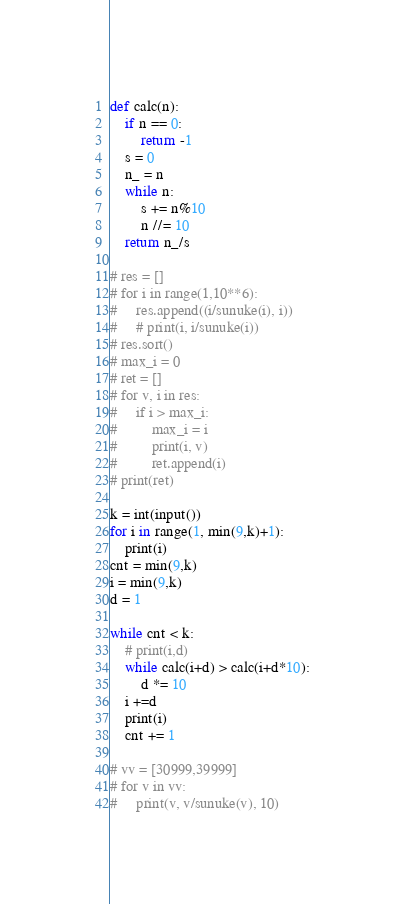<code> <loc_0><loc_0><loc_500><loc_500><_Python_>def calc(n):
    if n == 0:
        return -1
    s = 0
    n_ = n
    while n:
        s += n%10
        n //= 10
    return n_/s

# res = []
# for i in range(1,10**6):
#     res.append((i/sunuke(i), i))
#     # print(i, i/sunuke(i))
# res.sort()
# max_i = 0
# ret = []
# for v, i in res:
#     if i > max_i:
#         max_i = i
#         print(i, v)
#         ret.append(i)
# print(ret)

k = int(input())
for i in range(1, min(9,k)+1):
    print(i)
cnt = min(9,k)
i = min(9,k)
d = 1

while cnt < k:
    # print(i,d)
    while calc(i+d) > calc(i+d*10):
        d *= 10
    i +=d
    print(i)
    cnt += 1

# vv = [30999,39999]
# for v in vv:
#     print(v, v/sunuke(v), 10)</code> 